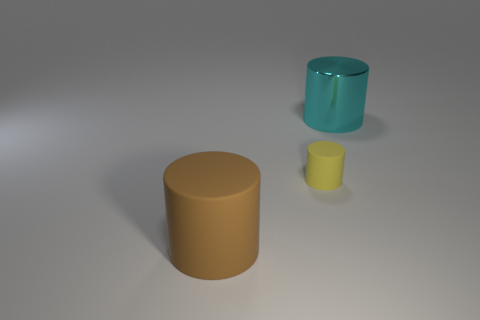Add 3 large shiny spheres. How many objects exist? 6 Subtract all cyan cylinders. How many cylinders are left? 2 Subtract all yellow cylinders. How many cylinders are left? 2 Subtract 2 cylinders. How many cylinders are left? 1 Subtract all blue cylinders. Subtract all yellow balls. How many cylinders are left? 3 Subtract all small yellow cylinders. Subtract all yellow rubber objects. How many objects are left? 1 Add 1 cyan objects. How many cyan objects are left? 2 Add 2 tiny yellow rubber blocks. How many tiny yellow rubber blocks exist? 2 Subtract 0 cyan blocks. How many objects are left? 3 